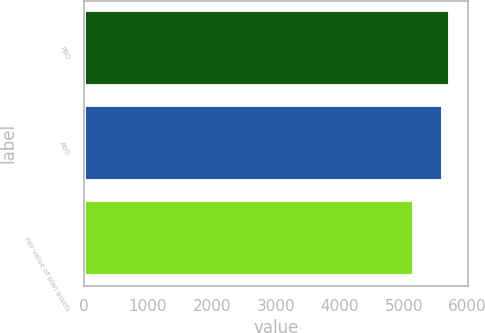<chart> <loc_0><loc_0><loc_500><loc_500><bar_chart><fcel>PBO<fcel>ABO<fcel>Fair value of plan assets<nl><fcel>5722<fcel>5622<fcel>5163<nl></chart> 